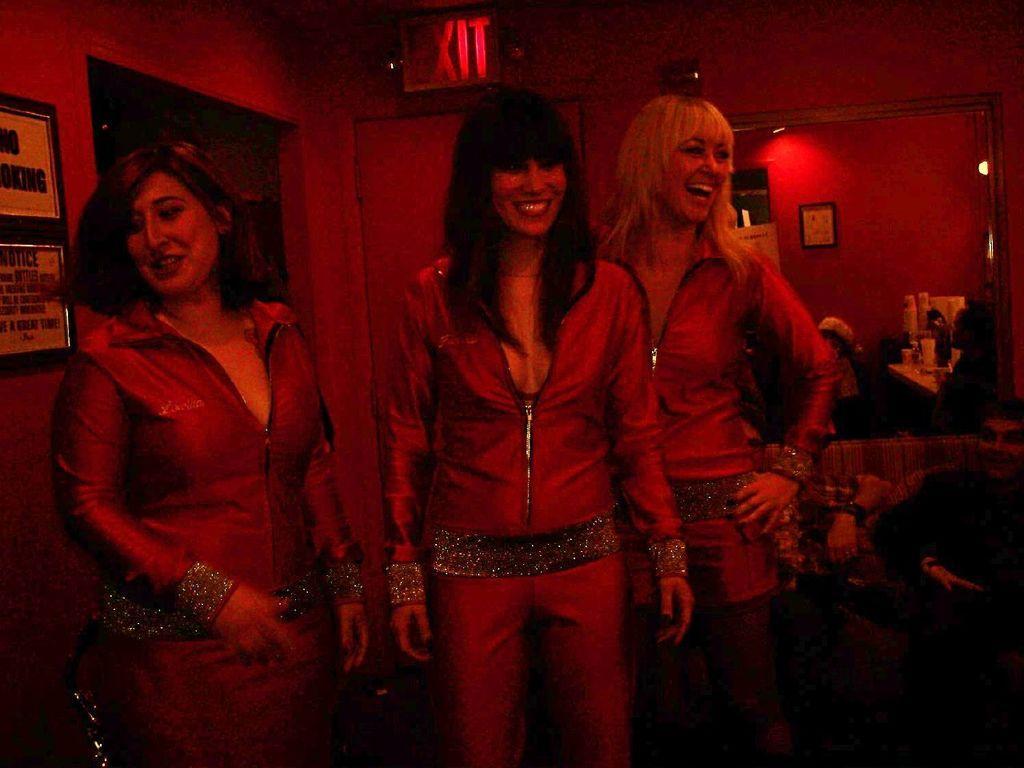In one or two sentences, can you explain what this image depicts? In this picture there are girls in the center of the image and there is a door behind them and there is an exit board at the top side of the image, there are other people in the background area of the image and there are portraits on the wall. 